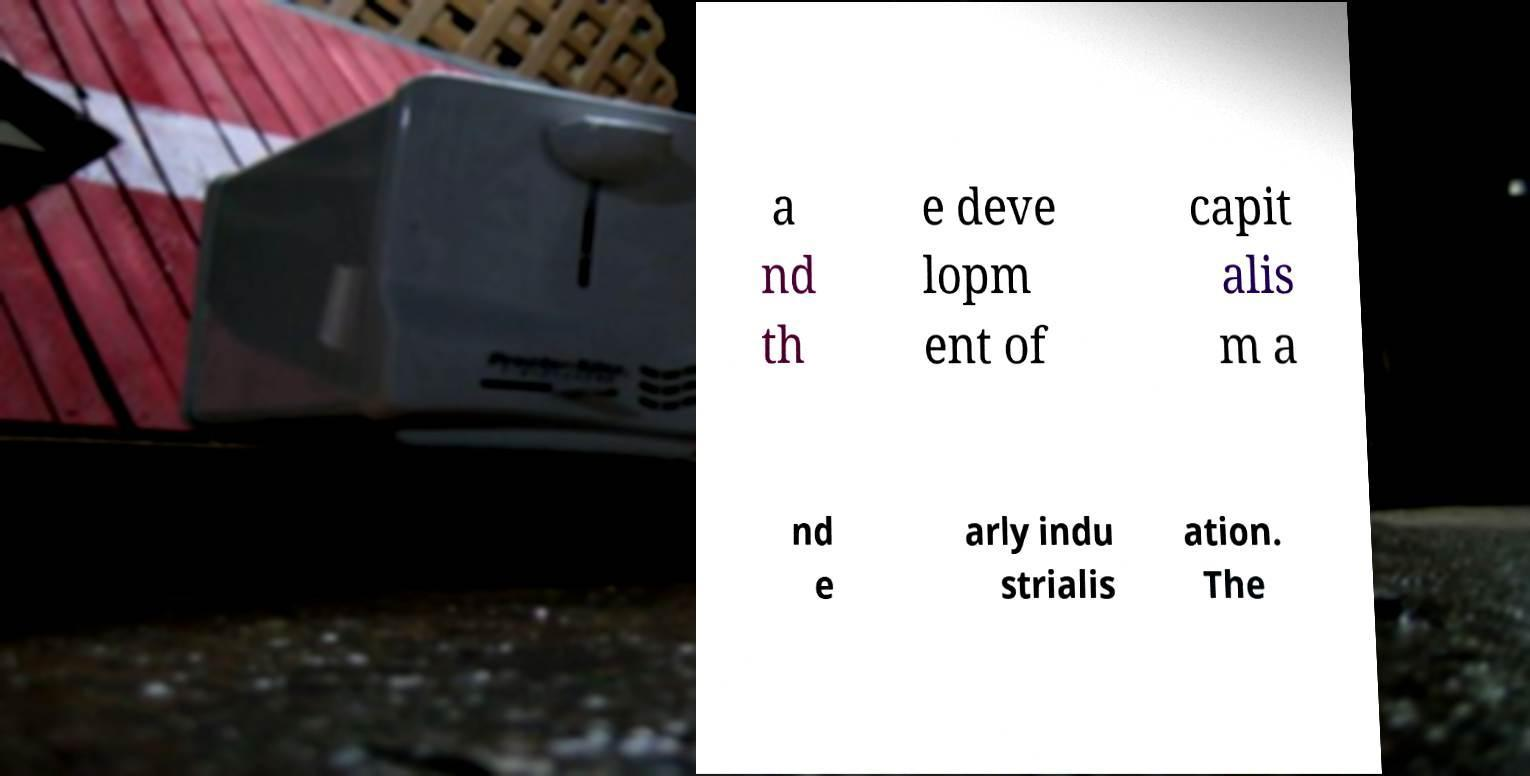Can you accurately transcribe the text from the provided image for me? a nd th e deve lopm ent of capit alis m a nd e arly indu strialis ation. The 